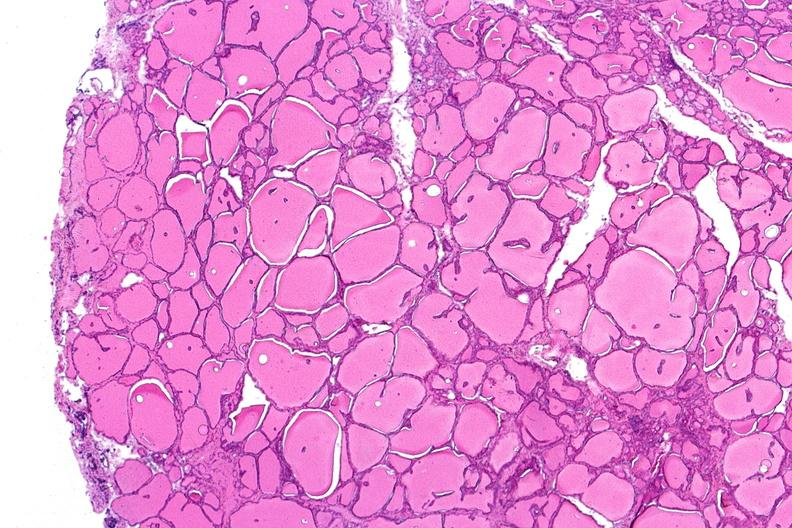what is present?
Answer the question using a single word or phrase. Endocrine 